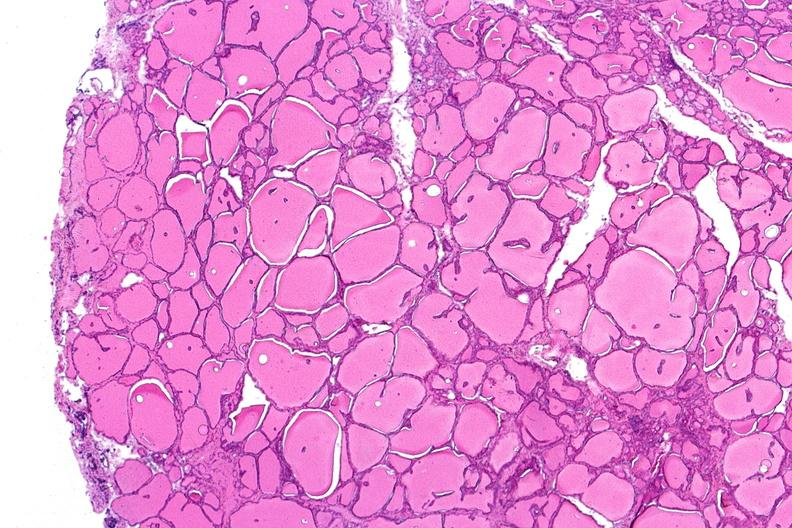what is present?
Answer the question using a single word or phrase. Endocrine 